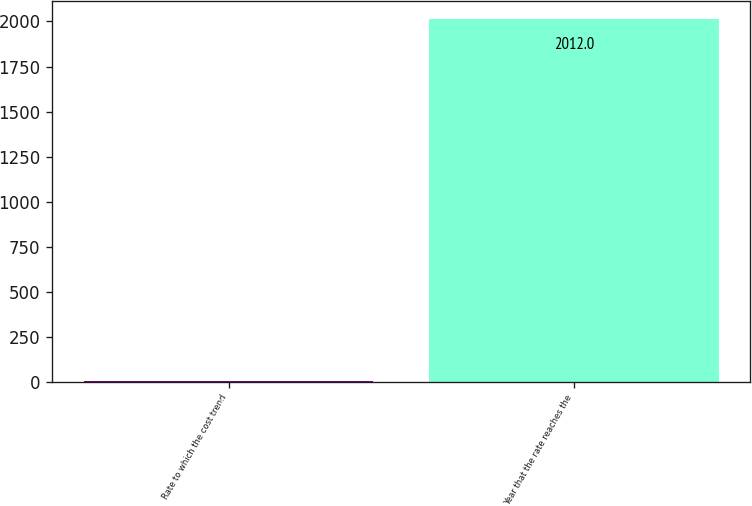Convert chart. <chart><loc_0><loc_0><loc_500><loc_500><bar_chart><fcel>Rate to which the cost trend<fcel>Year that the rate reaches the<nl><fcel>5<fcel>2012<nl></chart> 